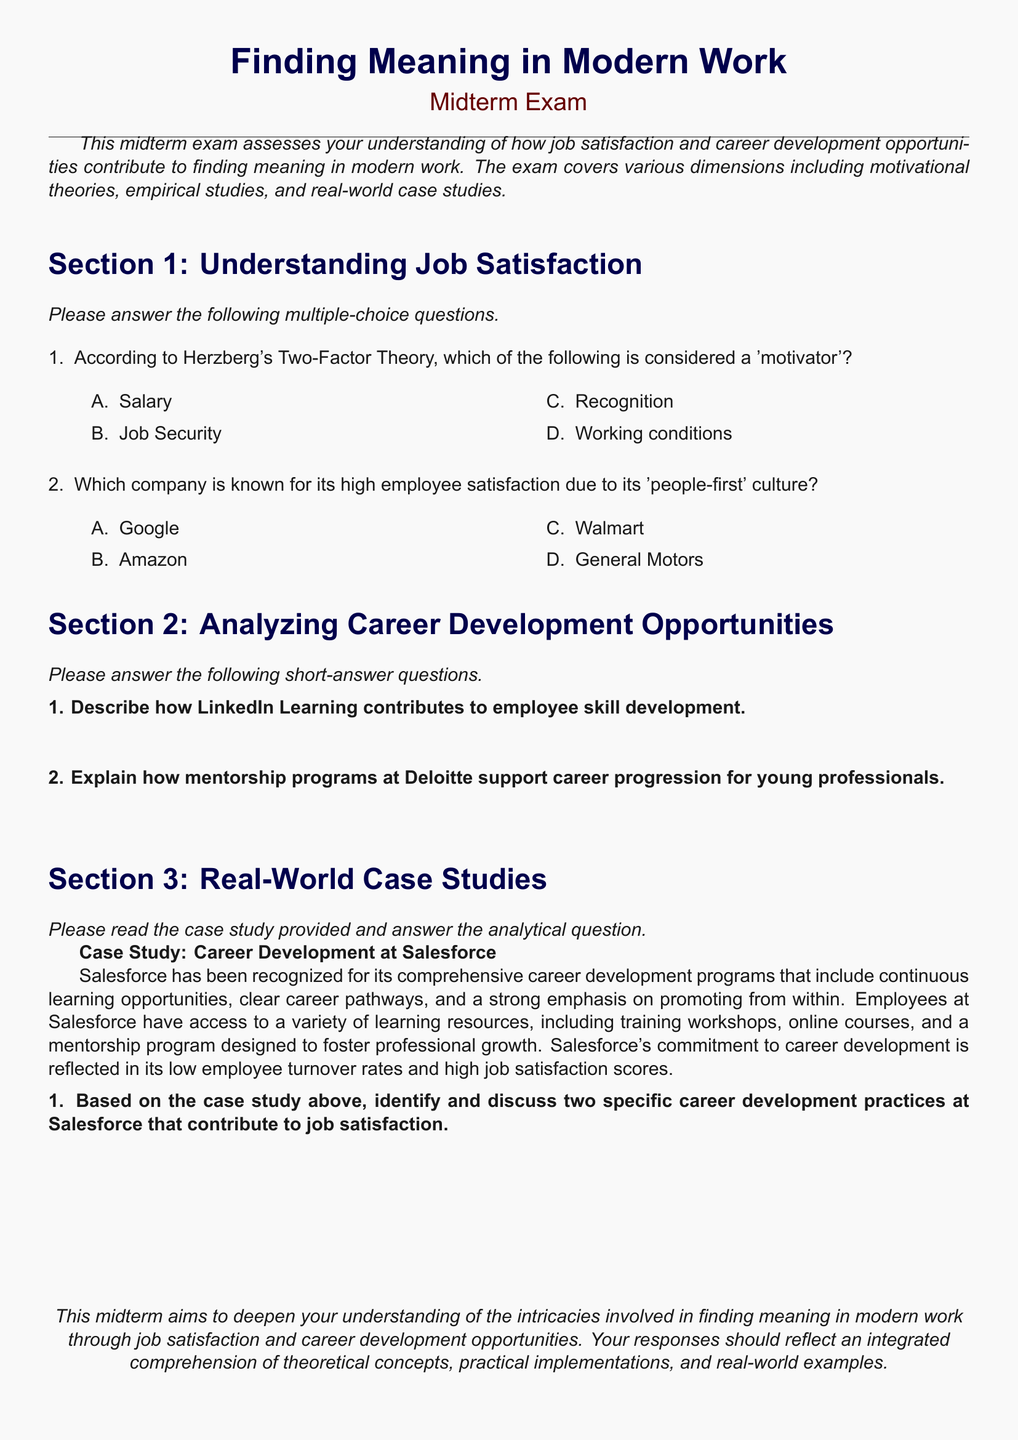What is the title of the midterm exam? The title of the midterm exam is stated at the top of the document as "Finding Meaning in Modern Work".
Answer: Finding Meaning in Modern Work Which theory is referenced in Section 1? The theory referenced in Section 1 is Herzberg's Two-Factor Theory, which is mentioned in the multiple-choice questions.
Answer: Herzberg's Two-Factor Theory What is one company known for a 'people-first' culture? The company known for its 'people-first' culture as listed in the multiple-choice options is Google.
Answer: Google How does LinkedIn Learning contribute to employee skill development? LinkedIn Learning's role in employee skill development is to provide learning resources and opportunities, as stated in the short-answer questions.
Answer: Learning resources What is Salesforce's approach to career development? Salesforce's approach to career development includes continuous learning opportunities and promoting from within, as detailed in the case study.
Answer: Continuous learning How does the document suggest mentorship programs assist professionals? The document mentions that mentorship programs at Deloitte support career progression for young professionals in the short-answer questions.
Answer: Career progression What is the consequence of Salesforce's commitment to career development? The consequence of Salesforce's commitment to career development, as mentioned in the case study, is low employee turnover rates.
Answer: Low employee turnover rates Which section contains multiple-choice questions? The section that contains multiple-choice questions is Section 1, as indicated in the document.
Answer: Section 1 What type of exam format is used in this document? The exam format used in this document is a midterm exam, which is specified at the beginning.
Answer: Midterm exam 